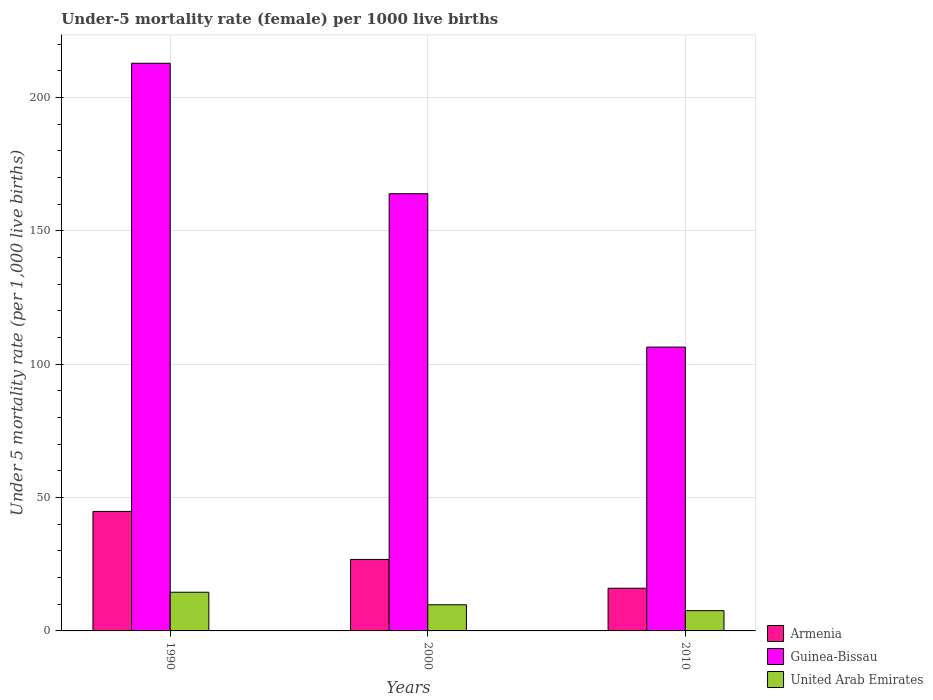How many different coloured bars are there?
Ensure brevity in your answer.  3. Are the number of bars per tick equal to the number of legend labels?
Make the answer very short. Yes. Are the number of bars on each tick of the X-axis equal?
Ensure brevity in your answer.  Yes. How many bars are there on the 1st tick from the left?
Offer a very short reply. 3. How many bars are there on the 3rd tick from the right?
Provide a short and direct response. 3. What is the under-five mortality rate in Armenia in 2000?
Ensure brevity in your answer.  26.8. Across all years, what is the maximum under-five mortality rate in United Arab Emirates?
Keep it short and to the point. 14.5. In which year was the under-five mortality rate in United Arab Emirates maximum?
Your answer should be very brief. 1990. In which year was the under-five mortality rate in Guinea-Bissau minimum?
Provide a succinct answer. 2010. What is the total under-five mortality rate in Guinea-Bissau in the graph?
Your response must be concise. 483.1. What is the difference between the under-five mortality rate in Armenia in 1990 and that in 2010?
Your answer should be very brief. 28.8. What is the difference between the under-five mortality rate in Armenia in 2000 and the under-five mortality rate in Guinea-Bissau in 1990?
Offer a very short reply. -186. What is the average under-five mortality rate in Armenia per year?
Make the answer very short. 29.2. In the year 2010, what is the difference between the under-five mortality rate in Armenia and under-five mortality rate in Guinea-Bissau?
Your response must be concise. -90.4. In how many years, is the under-five mortality rate in United Arab Emirates greater than 160?
Your response must be concise. 0. What is the ratio of the under-five mortality rate in United Arab Emirates in 1990 to that in 2010?
Provide a succinct answer. 1.91. Is the under-five mortality rate in United Arab Emirates in 2000 less than that in 2010?
Keep it short and to the point. No. Is the difference between the under-five mortality rate in Armenia in 1990 and 2010 greater than the difference between the under-five mortality rate in Guinea-Bissau in 1990 and 2010?
Provide a succinct answer. No. What is the difference between the highest and the second highest under-five mortality rate in Armenia?
Your answer should be compact. 18. What is the difference between the highest and the lowest under-five mortality rate in United Arab Emirates?
Ensure brevity in your answer.  6.9. In how many years, is the under-five mortality rate in Guinea-Bissau greater than the average under-five mortality rate in Guinea-Bissau taken over all years?
Keep it short and to the point. 2. Is the sum of the under-five mortality rate in Armenia in 2000 and 2010 greater than the maximum under-five mortality rate in Guinea-Bissau across all years?
Provide a succinct answer. No. What does the 3rd bar from the left in 2000 represents?
Offer a very short reply. United Arab Emirates. What does the 3rd bar from the right in 2010 represents?
Offer a terse response. Armenia. Are all the bars in the graph horizontal?
Provide a succinct answer. No. How many years are there in the graph?
Your response must be concise. 3. What is the difference between two consecutive major ticks on the Y-axis?
Ensure brevity in your answer.  50. Does the graph contain grids?
Ensure brevity in your answer.  Yes. Where does the legend appear in the graph?
Offer a very short reply. Bottom right. How many legend labels are there?
Offer a very short reply. 3. What is the title of the graph?
Ensure brevity in your answer.  Under-5 mortality rate (female) per 1000 live births. Does "Greece" appear as one of the legend labels in the graph?
Your response must be concise. No. What is the label or title of the X-axis?
Make the answer very short. Years. What is the label or title of the Y-axis?
Your answer should be very brief. Under 5 mortality rate (per 1,0 live births). What is the Under 5 mortality rate (per 1,000 live births) in Armenia in 1990?
Your answer should be very brief. 44.8. What is the Under 5 mortality rate (per 1,000 live births) of Guinea-Bissau in 1990?
Provide a succinct answer. 212.8. What is the Under 5 mortality rate (per 1,000 live births) in Armenia in 2000?
Give a very brief answer. 26.8. What is the Under 5 mortality rate (per 1,000 live births) of Guinea-Bissau in 2000?
Offer a terse response. 163.9. What is the Under 5 mortality rate (per 1,000 live births) of Armenia in 2010?
Provide a short and direct response. 16. What is the Under 5 mortality rate (per 1,000 live births) in Guinea-Bissau in 2010?
Provide a short and direct response. 106.4. Across all years, what is the maximum Under 5 mortality rate (per 1,000 live births) in Armenia?
Offer a very short reply. 44.8. Across all years, what is the maximum Under 5 mortality rate (per 1,000 live births) in Guinea-Bissau?
Give a very brief answer. 212.8. Across all years, what is the minimum Under 5 mortality rate (per 1,000 live births) in Guinea-Bissau?
Offer a very short reply. 106.4. Across all years, what is the minimum Under 5 mortality rate (per 1,000 live births) of United Arab Emirates?
Provide a short and direct response. 7.6. What is the total Under 5 mortality rate (per 1,000 live births) in Armenia in the graph?
Provide a succinct answer. 87.6. What is the total Under 5 mortality rate (per 1,000 live births) in Guinea-Bissau in the graph?
Provide a succinct answer. 483.1. What is the total Under 5 mortality rate (per 1,000 live births) in United Arab Emirates in the graph?
Keep it short and to the point. 31.9. What is the difference between the Under 5 mortality rate (per 1,000 live births) in Guinea-Bissau in 1990 and that in 2000?
Offer a very short reply. 48.9. What is the difference between the Under 5 mortality rate (per 1,000 live births) in Armenia in 1990 and that in 2010?
Your answer should be compact. 28.8. What is the difference between the Under 5 mortality rate (per 1,000 live births) of Guinea-Bissau in 1990 and that in 2010?
Give a very brief answer. 106.4. What is the difference between the Under 5 mortality rate (per 1,000 live births) of Guinea-Bissau in 2000 and that in 2010?
Your response must be concise. 57.5. What is the difference between the Under 5 mortality rate (per 1,000 live births) in United Arab Emirates in 2000 and that in 2010?
Give a very brief answer. 2.2. What is the difference between the Under 5 mortality rate (per 1,000 live births) of Armenia in 1990 and the Under 5 mortality rate (per 1,000 live births) of Guinea-Bissau in 2000?
Provide a succinct answer. -119.1. What is the difference between the Under 5 mortality rate (per 1,000 live births) of Armenia in 1990 and the Under 5 mortality rate (per 1,000 live births) of United Arab Emirates in 2000?
Provide a short and direct response. 35. What is the difference between the Under 5 mortality rate (per 1,000 live births) in Guinea-Bissau in 1990 and the Under 5 mortality rate (per 1,000 live births) in United Arab Emirates in 2000?
Offer a very short reply. 203. What is the difference between the Under 5 mortality rate (per 1,000 live births) of Armenia in 1990 and the Under 5 mortality rate (per 1,000 live births) of Guinea-Bissau in 2010?
Your response must be concise. -61.6. What is the difference between the Under 5 mortality rate (per 1,000 live births) of Armenia in 1990 and the Under 5 mortality rate (per 1,000 live births) of United Arab Emirates in 2010?
Provide a short and direct response. 37.2. What is the difference between the Under 5 mortality rate (per 1,000 live births) of Guinea-Bissau in 1990 and the Under 5 mortality rate (per 1,000 live births) of United Arab Emirates in 2010?
Provide a short and direct response. 205.2. What is the difference between the Under 5 mortality rate (per 1,000 live births) of Armenia in 2000 and the Under 5 mortality rate (per 1,000 live births) of Guinea-Bissau in 2010?
Offer a very short reply. -79.6. What is the difference between the Under 5 mortality rate (per 1,000 live births) of Guinea-Bissau in 2000 and the Under 5 mortality rate (per 1,000 live births) of United Arab Emirates in 2010?
Ensure brevity in your answer.  156.3. What is the average Under 5 mortality rate (per 1,000 live births) of Armenia per year?
Provide a succinct answer. 29.2. What is the average Under 5 mortality rate (per 1,000 live births) in Guinea-Bissau per year?
Your answer should be very brief. 161.03. What is the average Under 5 mortality rate (per 1,000 live births) in United Arab Emirates per year?
Provide a short and direct response. 10.63. In the year 1990, what is the difference between the Under 5 mortality rate (per 1,000 live births) of Armenia and Under 5 mortality rate (per 1,000 live births) of Guinea-Bissau?
Your answer should be compact. -168. In the year 1990, what is the difference between the Under 5 mortality rate (per 1,000 live births) of Armenia and Under 5 mortality rate (per 1,000 live births) of United Arab Emirates?
Make the answer very short. 30.3. In the year 1990, what is the difference between the Under 5 mortality rate (per 1,000 live births) in Guinea-Bissau and Under 5 mortality rate (per 1,000 live births) in United Arab Emirates?
Provide a short and direct response. 198.3. In the year 2000, what is the difference between the Under 5 mortality rate (per 1,000 live births) of Armenia and Under 5 mortality rate (per 1,000 live births) of Guinea-Bissau?
Offer a terse response. -137.1. In the year 2000, what is the difference between the Under 5 mortality rate (per 1,000 live births) in Armenia and Under 5 mortality rate (per 1,000 live births) in United Arab Emirates?
Your answer should be compact. 17. In the year 2000, what is the difference between the Under 5 mortality rate (per 1,000 live births) of Guinea-Bissau and Under 5 mortality rate (per 1,000 live births) of United Arab Emirates?
Your answer should be very brief. 154.1. In the year 2010, what is the difference between the Under 5 mortality rate (per 1,000 live births) of Armenia and Under 5 mortality rate (per 1,000 live births) of Guinea-Bissau?
Ensure brevity in your answer.  -90.4. In the year 2010, what is the difference between the Under 5 mortality rate (per 1,000 live births) of Guinea-Bissau and Under 5 mortality rate (per 1,000 live births) of United Arab Emirates?
Your answer should be very brief. 98.8. What is the ratio of the Under 5 mortality rate (per 1,000 live births) in Armenia in 1990 to that in 2000?
Make the answer very short. 1.67. What is the ratio of the Under 5 mortality rate (per 1,000 live births) in Guinea-Bissau in 1990 to that in 2000?
Ensure brevity in your answer.  1.3. What is the ratio of the Under 5 mortality rate (per 1,000 live births) in United Arab Emirates in 1990 to that in 2000?
Provide a succinct answer. 1.48. What is the ratio of the Under 5 mortality rate (per 1,000 live births) of United Arab Emirates in 1990 to that in 2010?
Your answer should be very brief. 1.91. What is the ratio of the Under 5 mortality rate (per 1,000 live births) of Armenia in 2000 to that in 2010?
Keep it short and to the point. 1.68. What is the ratio of the Under 5 mortality rate (per 1,000 live births) in Guinea-Bissau in 2000 to that in 2010?
Make the answer very short. 1.54. What is the ratio of the Under 5 mortality rate (per 1,000 live births) of United Arab Emirates in 2000 to that in 2010?
Your response must be concise. 1.29. What is the difference between the highest and the second highest Under 5 mortality rate (per 1,000 live births) of Armenia?
Ensure brevity in your answer.  18. What is the difference between the highest and the second highest Under 5 mortality rate (per 1,000 live births) of Guinea-Bissau?
Your answer should be compact. 48.9. What is the difference between the highest and the second highest Under 5 mortality rate (per 1,000 live births) in United Arab Emirates?
Your answer should be compact. 4.7. What is the difference between the highest and the lowest Under 5 mortality rate (per 1,000 live births) in Armenia?
Provide a succinct answer. 28.8. What is the difference between the highest and the lowest Under 5 mortality rate (per 1,000 live births) of Guinea-Bissau?
Offer a terse response. 106.4. 